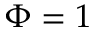<formula> <loc_0><loc_0><loc_500><loc_500>\Phi = 1</formula> 